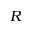Convert formula to latex. <formula><loc_0><loc_0><loc_500><loc_500>R</formula> 